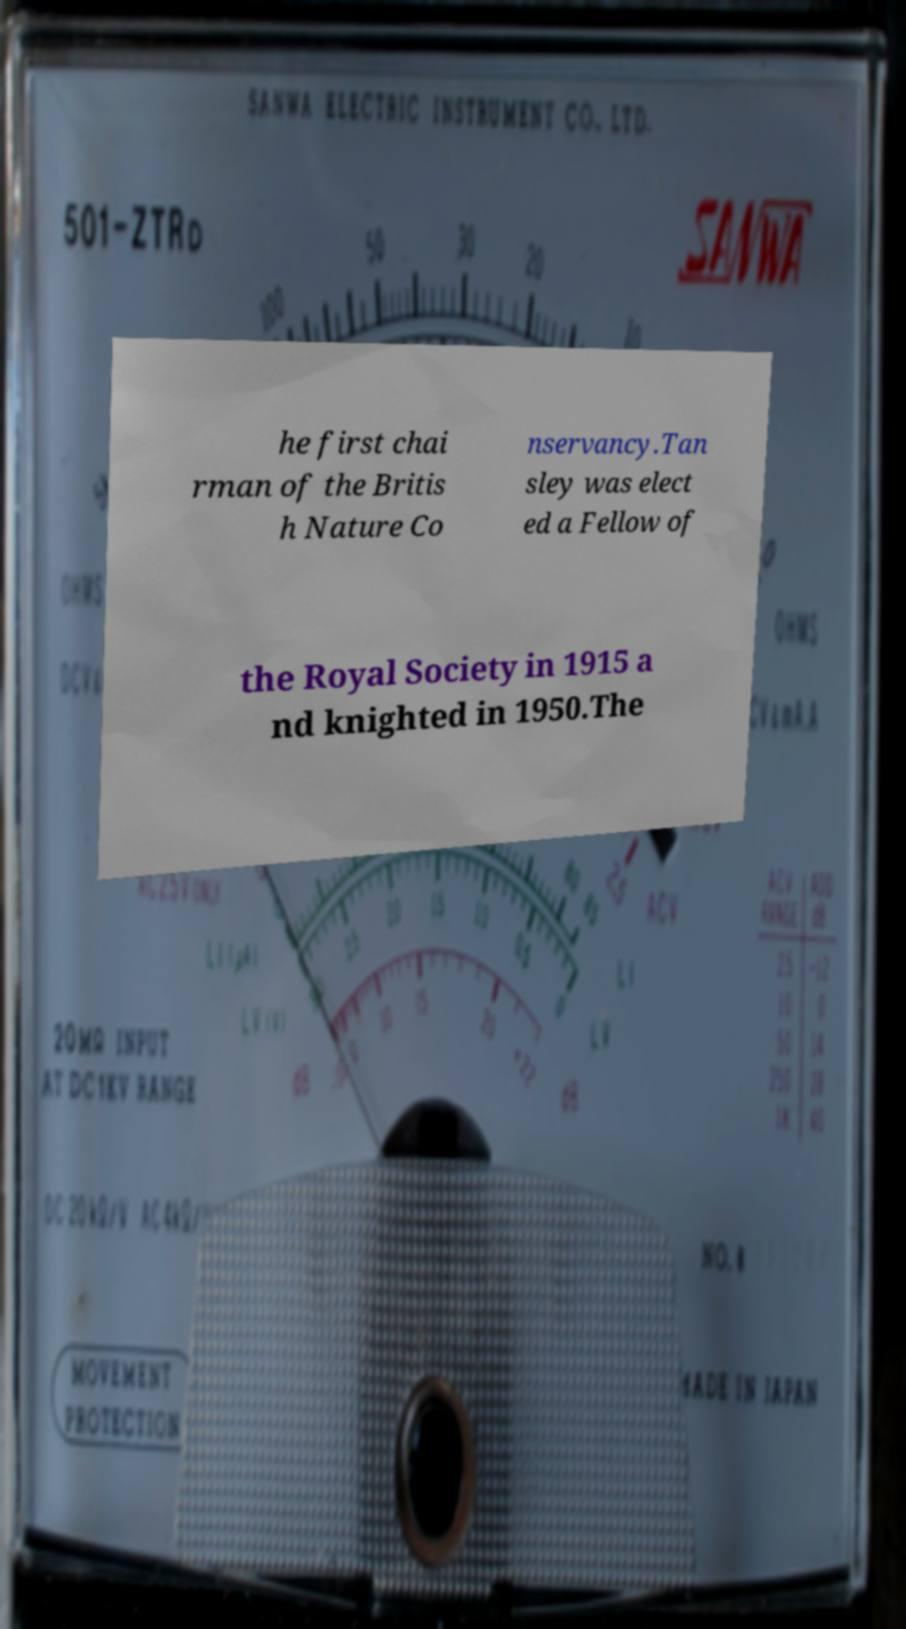Can you accurately transcribe the text from the provided image for me? he first chai rman of the Britis h Nature Co nservancy.Tan sley was elect ed a Fellow of the Royal Society in 1915 a nd knighted in 1950.The 